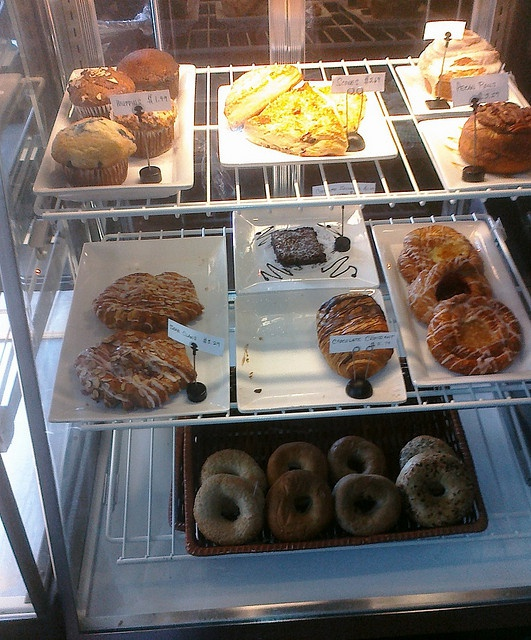Describe the objects in this image and their specific colors. I can see donut in gray and maroon tones, donut in gray, maroon, brown, and black tones, cake in gray, khaki, beige, and orange tones, donut in gray, maroon, and darkgray tones, and donut in gray and maroon tones in this image. 